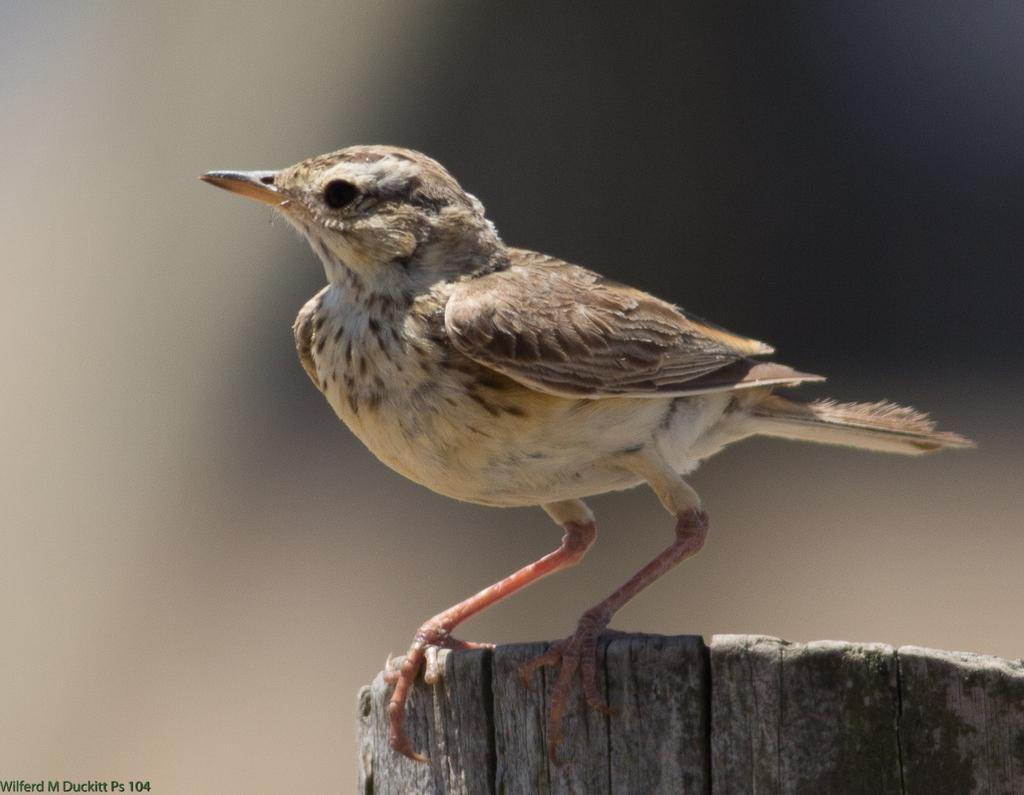What type of animal is in the image? There is a bird in the image. What is the bird sitting on? The bird is on a wooden object. Can you describe the background of the image? The background of the image is blurred. Is there any text or logo visible in the image? Yes, there is a watermark in the bottom left corner of the image. What type of humor can be seen in the image? There is no humor present in the image; it features a bird on a wooden object with a blurred background and a watermark. 